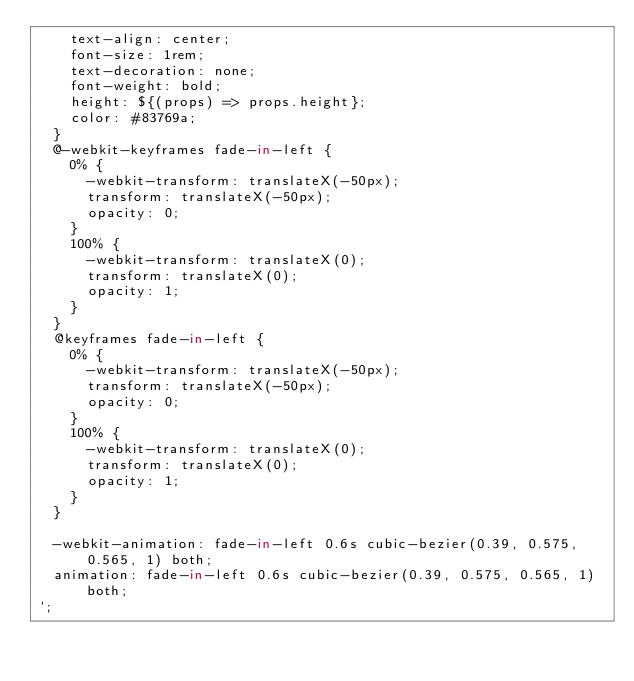<code> <loc_0><loc_0><loc_500><loc_500><_TypeScript_>    text-align: center;
    font-size: 1rem;
    text-decoration: none;
    font-weight: bold;
    height: ${(props) => props.height};
    color: #83769a;
  }
  @-webkit-keyframes fade-in-left {
    0% {
      -webkit-transform: translateX(-50px);
      transform: translateX(-50px);
      opacity: 0;
    }
    100% {
      -webkit-transform: translateX(0);
      transform: translateX(0);
      opacity: 1;
    }
  }
  @keyframes fade-in-left {
    0% {
      -webkit-transform: translateX(-50px);
      transform: translateX(-50px);
      opacity: 0;
    }
    100% {
      -webkit-transform: translateX(0);
      transform: translateX(0);
      opacity: 1;
    }
  }

  -webkit-animation: fade-in-left 0.6s cubic-bezier(0.39, 0.575, 0.565, 1) both;
  animation: fade-in-left 0.6s cubic-bezier(0.39, 0.575, 0.565, 1) both;
`;
</code> 